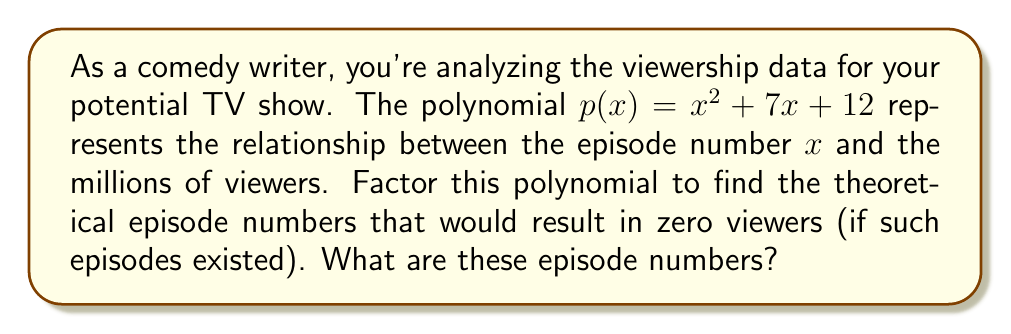Can you answer this question? Let's approach this step-by-step:

1) We need to factor the polynomial $p(x) = x^2 + 7x + 12$

2) This is a quadratic equation in the form $ax^2 + bx + c$, where $a=1$, $b=7$, and $c=12$

3) To factor this, we need to find two numbers that:
   - Multiply to give $ac = 1 \times 12 = 12$
   - Add up to give $b = 7$

4) The numbers that satisfy these conditions are 3 and 4

5) We can rewrite the middle term:
   $x^2 + 7x + 12 = x^2 + 3x + 4x + 12$

6) Now we can factor by grouping:
   $(x^2 + 3x) + (4x + 12)$
   $x(x + 3) + 4(x + 3)$
   $(x + 3)(x + 4)$

7) So, $p(x) = (x + 3)(x + 4)$

8) The roots of this polynomial (where $p(x) = 0$) are when either $(x + 3) = 0$ or $(x + 4) = 0$

9) Solving these:
   $x + 3 = 0$ gives $x = -3$
   $x + 4 = 0$ gives $x = -4$

10) These negative episode numbers don't make sense in reality, but they're the theoretical solutions to the polynomial.
Answer: $x = -3$ and $x = -4$ 